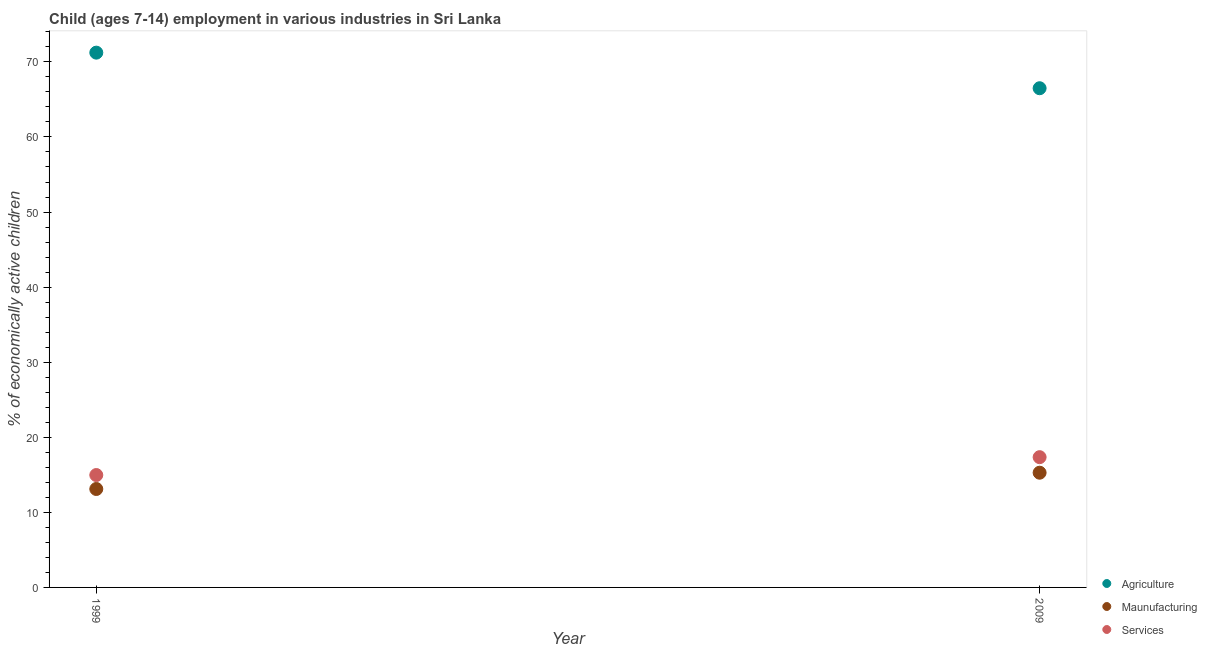Is the number of dotlines equal to the number of legend labels?
Keep it short and to the point. Yes. What is the percentage of economically active children in services in 2009?
Give a very brief answer. 17.35. Across all years, what is the maximum percentage of economically active children in agriculture?
Your answer should be very brief. 71.23. Across all years, what is the minimum percentage of economically active children in agriculture?
Ensure brevity in your answer.  66.49. In which year was the percentage of economically active children in manufacturing maximum?
Give a very brief answer. 2009. What is the total percentage of economically active children in services in the graph?
Offer a very short reply. 32.32. What is the difference between the percentage of economically active children in agriculture in 1999 and that in 2009?
Make the answer very short. 4.74. What is the difference between the percentage of economically active children in services in 1999 and the percentage of economically active children in manufacturing in 2009?
Keep it short and to the point. -0.31. What is the average percentage of economically active children in manufacturing per year?
Keep it short and to the point. 14.2. In the year 2009, what is the difference between the percentage of economically active children in services and percentage of economically active children in agriculture?
Your answer should be very brief. -49.14. What is the ratio of the percentage of economically active children in manufacturing in 1999 to that in 2009?
Keep it short and to the point. 0.86. Is the percentage of economically active children in agriculture in 1999 less than that in 2009?
Ensure brevity in your answer.  No. Is it the case that in every year, the sum of the percentage of economically active children in agriculture and percentage of economically active children in manufacturing is greater than the percentage of economically active children in services?
Your response must be concise. Yes. Does the percentage of economically active children in services monotonically increase over the years?
Keep it short and to the point. Yes. Is the percentage of economically active children in services strictly less than the percentage of economically active children in agriculture over the years?
Give a very brief answer. Yes. How many years are there in the graph?
Your answer should be compact. 2. Does the graph contain any zero values?
Your answer should be compact. No. Where does the legend appear in the graph?
Your answer should be very brief. Bottom right. How many legend labels are there?
Keep it short and to the point. 3. How are the legend labels stacked?
Give a very brief answer. Vertical. What is the title of the graph?
Provide a short and direct response. Child (ages 7-14) employment in various industries in Sri Lanka. What is the label or title of the X-axis?
Offer a very short reply. Year. What is the label or title of the Y-axis?
Make the answer very short. % of economically active children. What is the % of economically active children in Agriculture in 1999?
Make the answer very short. 71.23. What is the % of economically active children in Maunufacturing in 1999?
Offer a terse response. 13.11. What is the % of economically active children of Services in 1999?
Provide a short and direct response. 14.97. What is the % of economically active children in Agriculture in 2009?
Keep it short and to the point. 66.49. What is the % of economically active children in Maunufacturing in 2009?
Give a very brief answer. 15.28. What is the % of economically active children of Services in 2009?
Offer a very short reply. 17.35. Across all years, what is the maximum % of economically active children in Agriculture?
Keep it short and to the point. 71.23. Across all years, what is the maximum % of economically active children in Maunufacturing?
Keep it short and to the point. 15.28. Across all years, what is the maximum % of economically active children of Services?
Keep it short and to the point. 17.35. Across all years, what is the minimum % of economically active children of Agriculture?
Offer a terse response. 66.49. Across all years, what is the minimum % of economically active children in Maunufacturing?
Provide a short and direct response. 13.11. Across all years, what is the minimum % of economically active children in Services?
Your answer should be compact. 14.97. What is the total % of economically active children in Agriculture in the graph?
Ensure brevity in your answer.  137.72. What is the total % of economically active children of Maunufacturing in the graph?
Your response must be concise. 28.39. What is the total % of economically active children of Services in the graph?
Your response must be concise. 32.32. What is the difference between the % of economically active children of Agriculture in 1999 and that in 2009?
Your response must be concise. 4.74. What is the difference between the % of economically active children in Maunufacturing in 1999 and that in 2009?
Your answer should be very brief. -2.17. What is the difference between the % of economically active children of Services in 1999 and that in 2009?
Keep it short and to the point. -2.38. What is the difference between the % of economically active children of Agriculture in 1999 and the % of economically active children of Maunufacturing in 2009?
Keep it short and to the point. 55.95. What is the difference between the % of economically active children in Agriculture in 1999 and the % of economically active children in Services in 2009?
Your answer should be very brief. 53.88. What is the difference between the % of economically active children in Maunufacturing in 1999 and the % of economically active children in Services in 2009?
Make the answer very short. -4.24. What is the average % of economically active children in Agriculture per year?
Give a very brief answer. 68.86. What is the average % of economically active children of Maunufacturing per year?
Offer a terse response. 14.2. What is the average % of economically active children in Services per year?
Your answer should be compact. 16.16. In the year 1999, what is the difference between the % of economically active children of Agriculture and % of economically active children of Maunufacturing?
Keep it short and to the point. 58.12. In the year 1999, what is the difference between the % of economically active children of Agriculture and % of economically active children of Services?
Provide a short and direct response. 56.26. In the year 1999, what is the difference between the % of economically active children of Maunufacturing and % of economically active children of Services?
Your answer should be very brief. -1.86. In the year 2009, what is the difference between the % of economically active children of Agriculture and % of economically active children of Maunufacturing?
Your answer should be very brief. 51.21. In the year 2009, what is the difference between the % of economically active children in Agriculture and % of economically active children in Services?
Provide a succinct answer. 49.14. In the year 2009, what is the difference between the % of economically active children in Maunufacturing and % of economically active children in Services?
Your answer should be compact. -2.07. What is the ratio of the % of economically active children of Agriculture in 1999 to that in 2009?
Offer a terse response. 1.07. What is the ratio of the % of economically active children in Maunufacturing in 1999 to that in 2009?
Provide a succinct answer. 0.86. What is the ratio of the % of economically active children in Services in 1999 to that in 2009?
Give a very brief answer. 0.86. What is the difference between the highest and the second highest % of economically active children of Agriculture?
Keep it short and to the point. 4.74. What is the difference between the highest and the second highest % of economically active children in Maunufacturing?
Provide a short and direct response. 2.17. What is the difference between the highest and the second highest % of economically active children of Services?
Make the answer very short. 2.38. What is the difference between the highest and the lowest % of economically active children of Agriculture?
Give a very brief answer. 4.74. What is the difference between the highest and the lowest % of economically active children in Maunufacturing?
Your response must be concise. 2.17. What is the difference between the highest and the lowest % of economically active children in Services?
Your answer should be compact. 2.38. 